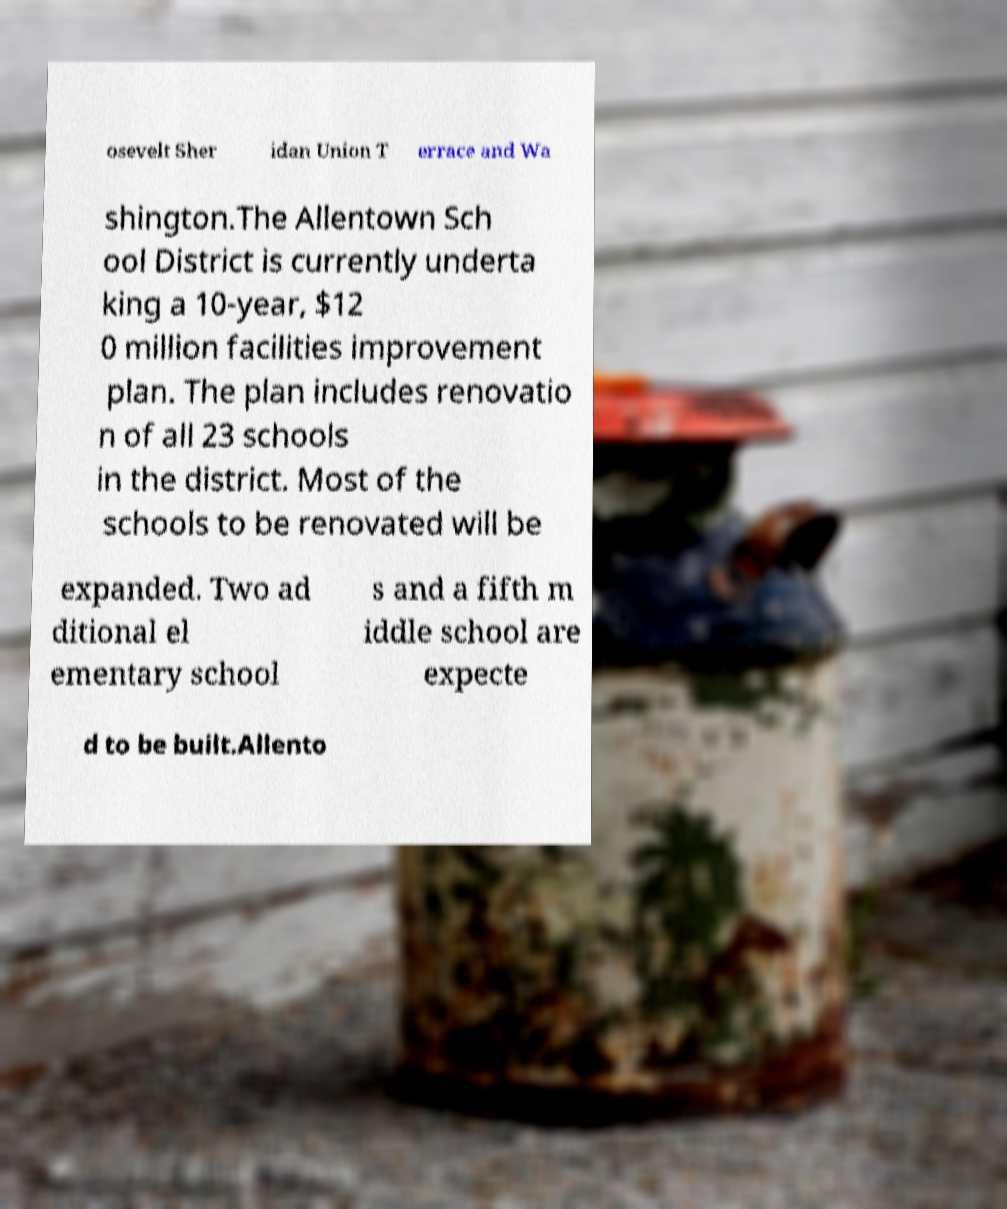Can you accurately transcribe the text from the provided image for me? osevelt Sher idan Union T errace and Wa shington.The Allentown Sch ool District is currently underta king a 10-year, $12 0 million facilities improvement plan. The plan includes renovatio n of all 23 schools in the district. Most of the schools to be renovated will be expanded. Two ad ditional el ementary school s and a fifth m iddle school are expecte d to be built.Allento 